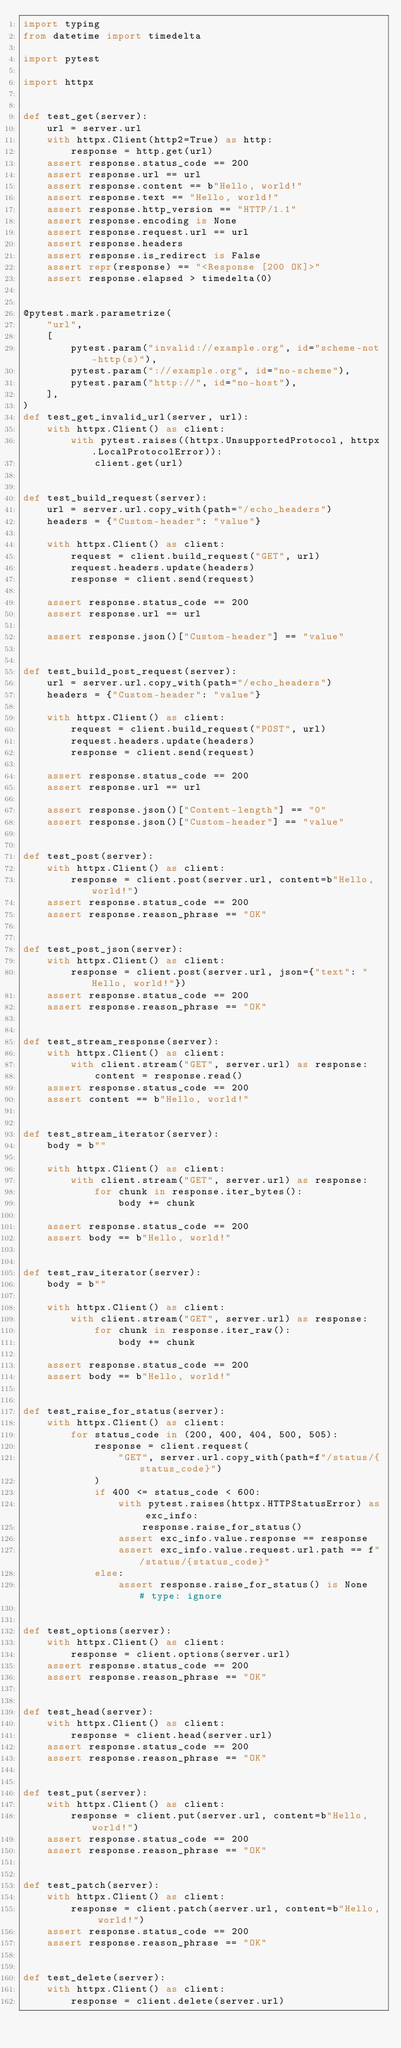Convert code to text. <code><loc_0><loc_0><loc_500><loc_500><_Python_>import typing
from datetime import timedelta

import pytest

import httpx


def test_get(server):
    url = server.url
    with httpx.Client(http2=True) as http:
        response = http.get(url)
    assert response.status_code == 200
    assert response.url == url
    assert response.content == b"Hello, world!"
    assert response.text == "Hello, world!"
    assert response.http_version == "HTTP/1.1"
    assert response.encoding is None
    assert response.request.url == url
    assert response.headers
    assert response.is_redirect is False
    assert repr(response) == "<Response [200 OK]>"
    assert response.elapsed > timedelta(0)


@pytest.mark.parametrize(
    "url",
    [
        pytest.param("invalid://example.org", id="scheme-not-http(s)"),
        pytest.param("://example.org", id="no-scheme"),
        pytest.param("http://", id="no-host"),
    ],
)
def test_get_invalid_url(server, url):
    with httpx.Client() as client:
        with pytest.raises((httpx.UnsupportedProtocol, httpx.LocalProtocolError)):
            client.get(url)


def test_build_request(server):
    url = server.url.copy_with(path="/echo_headers")
    headers = {"Custom-header": "value"}

    with httpx.Client() as client:
        request = client.build_request("GET", url)
        request.headers.update(headers)
        response = client.send(request)

    assert response.status_code == 200
    assert response.url == url

    assert response.json()["Custom-header"] == "value"


def test_build_post_request(server):
    url = server.url.copy_with(path="/echo_headers")
    headers = {"Custom-header": "value"}

    with httpx.Client() as client:
        request = client.build_request("POST", url)
        request.headers.update(headers)
        response = client.send(request)

    assert response.status_code == 200
    assert response.url == url

    assert response.json()["Content-length"] == "0"
    assert response.json()["Custom-header"] == "value"


def test_post(server):
    with httpx.Client() as client:
        response = client.post(server.url, content=b"Hello, world!")
    assert response.status_code == 200
    assert response.reason_phrase == "OK"


def test_post_json(server):
    with httpx.Client() as client:
        response = client.post(server.url, json={"text": "Hello, world!"})
    assert response.status_code == 200
    assert response.reason_phrase == "OK"


def test_stream_response(server):
    with httpx.Client() as client:
        with client.stream("GET", server.url) as response:
            content = response.read()
    assert response.status_code == 200
    assert content == b"Hello, world!"


def test_stream_iterator(server):
    body = b""

    with httpx.Client() as client:
        with client.stream("GET", server.url) as response:
            for chunk in response.iter_bytes():
                body += chunk

    assert response.status_code == 200
    assert body == b"Hello, world!"


def test_raw_iterator(server):
    body = b""

    with httpx.Client() as client:
        with client.stream("GET", server.url) as response:
            for chunk in response.iter_raw():
                body += chunk

    assert response.status_code == 200
    assert body == b"Hello, world!"


def test_raise_for_status(server):
    with httpx.Client() as client:
        for status_code in (200, 400, 404, 500, 505):
            response = client.request(
                "GET", server.url.copy_with(path=f"/status/{status_code}")
            )
            if 400 <= status_code < 600:
                with pytest.raises(httpx.HTTPStatusError) as exc_info:
                    response.raise_for_status()
                assert exc_info.value.response == response
                assert exc_info.value.request.url.path == f"/status/{status_code}"
            else:
                assert response.raise_for_status() is None  # type: ignore


def test_options(server):
    with httpx.Client() as client:
        response = client.options(server.url)
    assert response.status_code == 200
    assert response.reason_phrase == "OK"


def test_head(server):
    with httpx.Client() as client:
        response = client.head(server.url)
    assert response.status_code == 200
    assert response.reason_phrase == "OK"


def test_put(server):
    with httpx.Client() as client:
        response = client.put(server.url, content=b"Hello, world!")
    assert response.status_code == 200
    assert response.reason_phrase == "OK"


def test_patch(server):
    with httpx.Client() as client:
        response = client.patch(server.url, content=b"Hello, world!")
    assert response.status_code == 200
    assert response.reason_phrase == "OK"


def test_delete(server):
    with httpx.Client() as client:
        response = client.delete(server.url)</code> 